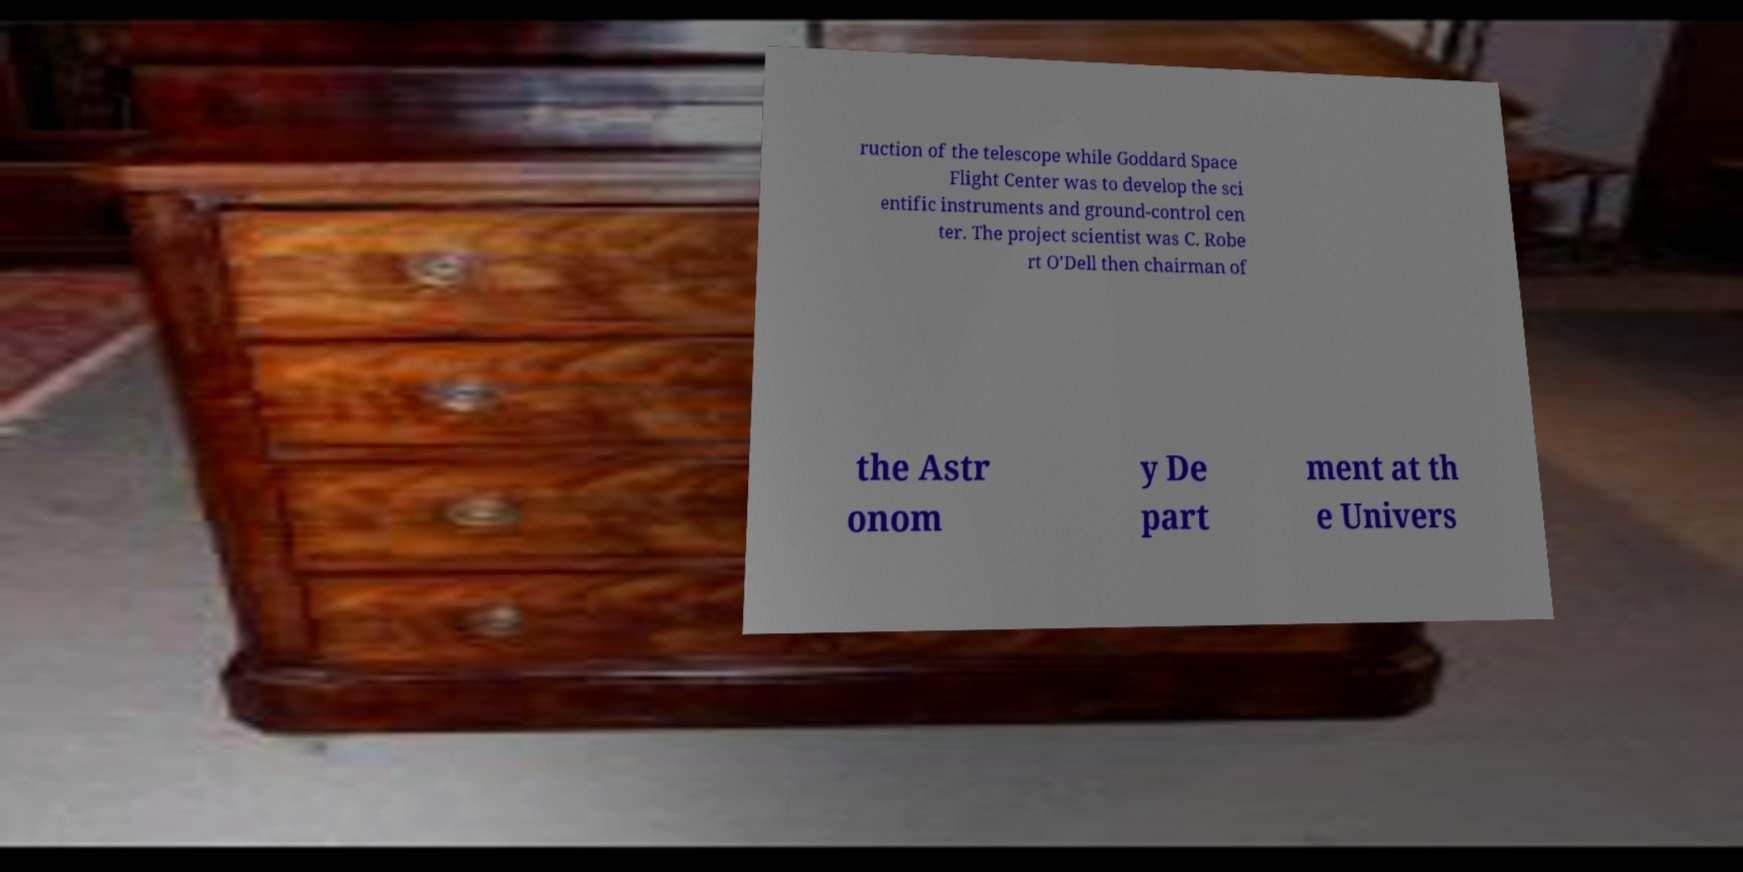Can you accurately transcribe the text from the provided image for me? ruction of the telescope while Goddard Space Flight Center was to develop the sci entific instruments and ground-control cen ter. The project scientist was C. Robe rt O’Dell then chairman of the Astr onom y De part ment at th e Univers 